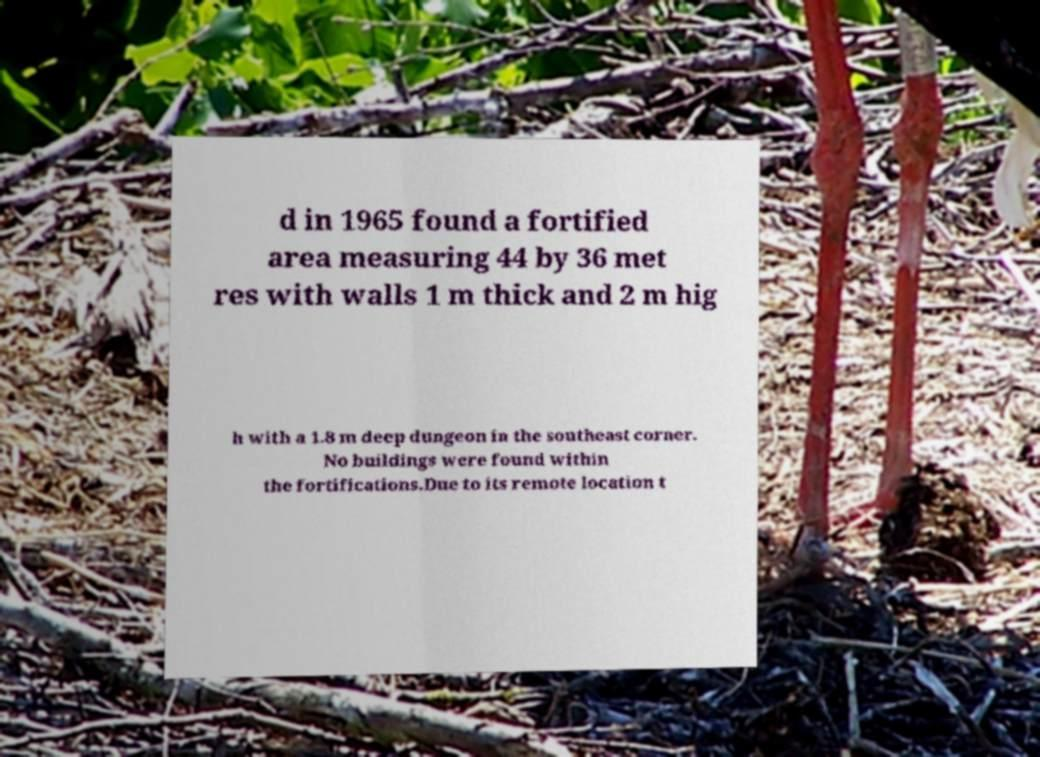Can you read and provide the text displayed in the image?This photo seems to have some interesting text. Can you extract and type it out for me? d in 1965 found a fortified area measuring 44 by 36 met res with walls 1 m thick and 2 m hig h with a 1.8 m deep dungeon in the southeast corner. No buildings were found within the fortifications.Due to its remote location t 